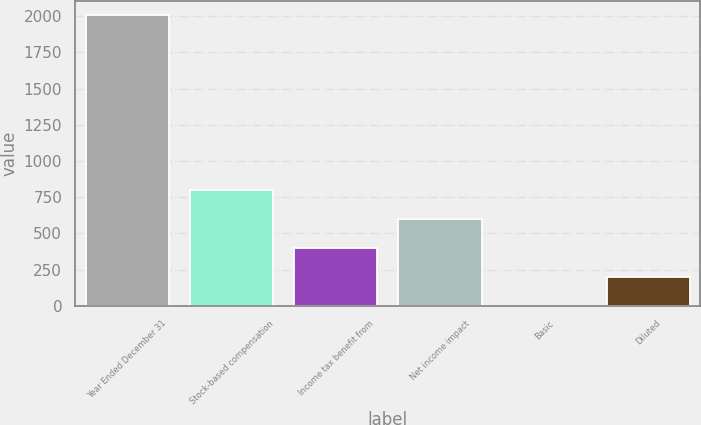<chart> <loc_0><loc_0><loc_500><loc_500><bar_chart><fcel>Year Ended December 31<fcel>Stock-based compensation<fcel>Income tax benefit from<fcel>Net income impact<fcel>Basic<fcel>Diluted<nl><fcel>2006<fcel>802.43<fcel>401.23<fcel>601.83<fcel>0.03<fcel>200.63<nl></chart> 